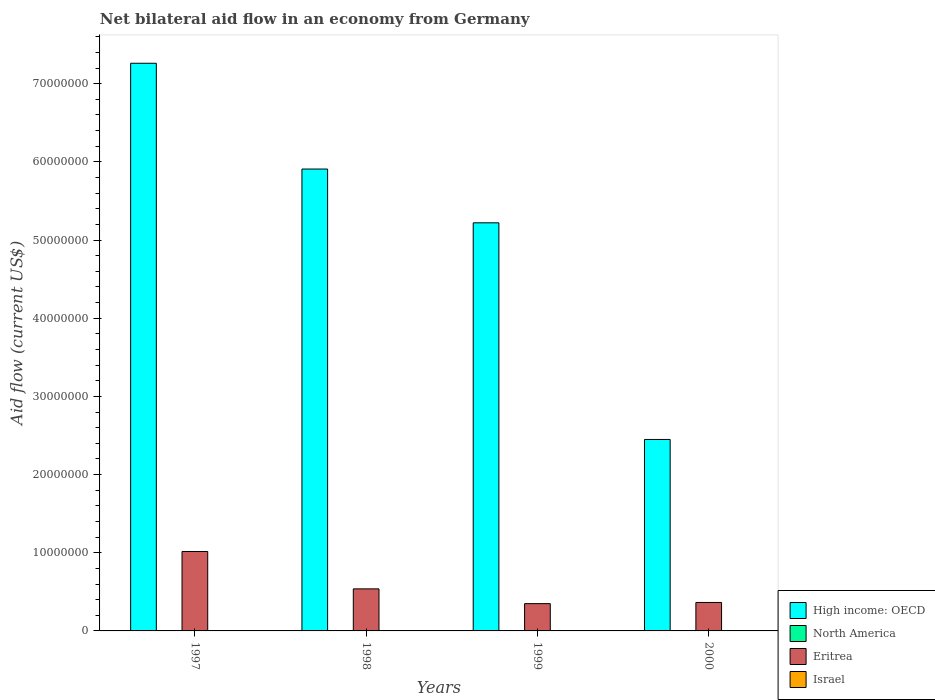How many groups of bars are there?
Your response must be concise. 4. Are the number of bars per tick equal to the number of legend labels?
Your answer should be very brief. No. Are the number of bars on each tick of the X-axis equal?
Offer a very short reply. No. In how many cases, is the number of bars for a given year not equal to the number of legend labels?
Your answer should be very brief. 4. What is the net bilateral aid flow in Eritrea in 1998?
Give a very brief answer. 5.38e+06. Across all years, what is the maximum net bilateral aid flow in Eritrea?
Provide a short and direct response. 1.02e+07. Across all years, what is the minimum net bilateral aid flow in High income: OECD?
Ensure brevity in your answer.  2.45e+07. In which year was the net bilateral aid flow in Eritrea maximum?
Ensure brevity in your answer.  1997. What is the total net bilateral aid flow in High income: OECD in the graph?
Your response must be concise. 2.08e+08. What is the difference between the net bilateral aid flow in Israel in 1998 and the net bilateral aid flow in High income: OECD in 1999?
Your response must be concise. -5.22e+07. What is the average net bilateral aid flow in North America per year?
Ensure brevity in your answer.  1.25e+04. In the year 1998, what is the difference between the net bilateral aid flow in Eritrea and net bilateral aid flow in High income: OECD?
Your answer should be compact. -5.37e+07. What is the ratio of the net bilateral aid flow in Eritrea in 1997 to that in 2000?
Ensure brevity in your answer.  2.79. Is the net bilateral aid flow in Eritrea in 1997 less than that in 2000?
Make the answer very short. No. What is the difference between the highest and the second highest net bilateral aid flow in Eritrea?
Your answer should be very brief. 4.78e+06. Is the sum of the net bilateral aid flow in High income: OECD in 1999 and 2000 greater than the maximum net bilateral aid flow in North America across all years?
Your response must be concise. Yes. Is it the case that in every year, the sum of the net bilateral aid flow in North America and net bilateral aid flow in High income: OECD is greater than the sum of net bilateral aid flow in Eritrea and net bilateral aid flow in Israel?
Make the answer very short. No. How many bars are there?
Keep it short and to the point. 11. Are all the bars in the graph horizontal?
Your answer should be compact. No. How many years are there in the graph?
Your answer should be very brief. 4. Does the graph contain any zero values?
Provide a succinct answer. Yes. Does the graph contain grids?
Your answer should be very brief. No. Where does the legend appear in the graph?
Provide a short and direct response. Bottom right. How many legend labels are there?
Ensure brevity in your answer.  4. What is the title of the graph?
Offer a very short reply. Net bilateral aid flow in an economy from Germany. Does "Vanuatu" appear as one of the legend labels in the graph?
Provide a short and direct response. No. What is the label or title of the X-axis?
Offer a terse response. Years. What is the label or title of the Y-axis?
Give a very brief answer. Aid flow (current US$). What is the Aid flow (current US$) of High income: OECD in 1997?
Ensure brevity in your answer.  7.26e+07. What is the Aid flow (current US$) in Eritrea in 1997?
Provide a succinct answer. 1.02e+07. What is the Aid flow (current US$) in High income: OECD in 1998?
Your response must be concise. 5.91e+07. What is the Aid flow (current US$) in Eritrea in 1998?
Provide a short and direct response. 5.38e+06. What is the Aid flow (current US$) of High income: OECD in 1999?
Make the answer very short. 5.22e+07. What is the Aid flow (current US$) of Eritrea in 1999?
Your response must be concise. 3.49e+06. What is the Aid flow (current US$) of High income: OECD in 2000?
Your answer should be very brief. 2.45e+07. What is the Aid flow (current US$) of North America in 2000?
Ensure brevity in your answer.  10000. What is the Aid flow (current US$) of Eritrea in 2000?
Provide a short and direct response. 3.64e+06. What is the Aid flow (current US$) in Israel in 2000?
Ensure brevity in your answer.  0. Across all years, what is the maximum Aid flow (current US$) of High income: OECD?
Give a very brief answer. 7.26e+07. Across all years, what is the maximum Aid flow (current US$) of Eritrea?
Make the answer very short. 1.02e+07. Across all years, what is the minimum Aid flow (current US$) of High income: OECD?
Your answer should be very brief. 2.45e+07. Across all years, what is the minimum Aid flow (current US$) in Eritrea?
Offer a very short reply. 3.49e+06. What is the total Aid flow (current US$) in High income: OECD in the graph?
Your answer should be very brief. 2.08e+08. What is the total Aid flow (current US$) of North America in the graph?
Give a very brief answer. 5.00e+04. What is the total Aid flow (current US$) in Eritrea in the graph?
Your response must be concise. 2.27e+07. What is the difference between the Aid flow (current US$) in High income: OECD in 1997 and that in 1998?
Ensure brevity in your answer.  1.35e+07. What is the difference between the Aid flow (current US$) in Eritrea in 1997 and that in 1998?
Your answer should be very brief. 4.78e+06. What is the difference between the Aid flow (current US$) in High income: OECD in 1997 and that in 1999?
Give a very brief answer. 2.04e+07. What is the difference between the Aid flow (current US$) in Eritrea in 1997 and that in 1999?
Ensure brevity in your answer.  6.67e+06. What is the difference between the Aid flow (current US$) of High income: OECD in 1997 and that in 2000?
Ensure brevity in your answer.  4.81e+07. What is the difference between the Aid flow (current US$) in Eritrea in 1997 and that in 2000?
Offer a terse response. 6.52e+06. What is the difference between the Aid flow (current US$) of High income: OECD in 1998 and that in 1999?
Provide a short and direct response. 6.88e+06. What is the difference between the Aid flow (current US$) in North America in 1998 and that in 1999?
Offer a very short reply. 0. What is the difference between the Aid flow (current US$) of Eritrea in 1998 and that in 1999?
Your response must be concise. 1.89e+06. What is the difference between the Aid flow (current US$) in High income: OECD in 1998 and that in 2000?
Your answer should be very brief. 3.46e+07. What is the difference between the Aid flow (current US$) of North America in 1998 and that in 2000?
Keep it short and to the point. 10000. What is the difference between the Aid flow (current US$) of Eritrea in 1998 and that in 2000?
Provide a short and direct response. 1.74e+06. What is the difference between the Aid flow (current US$) of High income: OECD in 1999 and that in 2000?
Offer a terse response. 2.77e+07. What is the difference between the Aid flow (current US$) in High income: OECD in 1997 and the Aid flow (current US$) in North America in 1998?
Make the answer very short. 7.26e+07. What is the difference between the Aid flow (current US$) in High income: OECD in 1997 and the Aid flow (current US$) in Eritrea in 1998?
Your response must be concise. 6.72e+07. What is the difference between the Aid flow (current US$) in High income: OECD in 1997 and the Aid flow (current US$) in North America in 1999?
Offer a very short reply. 7.26e+07. What is the difference between the Aid flow (current US$) in High income: OECD in 1997 and the Aid flow (current US$) in Eritrea in 1999?
Provide a succinct answer. 6.91e+07. What is the difference between the Aid flow (current US$) in High income: OECD in 1997 and the Aid flow (current US$) in North America in 2000?
Ensure brevity in your answer.  7.26e+07. What is the difference between the Aid flow (current US$) of High income: OECD in 1997 and the Aid flow (current US$) of Eritrea in 2000?
Your answer should be very brief. 6.90e+07. What is the difference between the Aid flow (current US$) in High income: OECD in 1998 and the Aid flow (current US$) in North America in 1999?
Give a very brief answer. 5.91e+07. What is the difference between the Aid flow (current US$) in High income: OECD in 1998 and the Aid flow (current US$) in Eritrea in 1999?
Provide a short and direct response. 5.56e+07. What is the difference between the Aid flow (current US$) of North America in 1998 and the Aid flow (current US$) of Eritrea in 1999?
Keep it short and to the point. -3.47e+06. What is the difference between the Aid flow (current US$) in High income: OECD in 1998 and the Aid flow (current US$) in North America in 2000?
Make the answer very short. 5.91e+07. What is the difference between the Aid flow (current US$) of High income: OECD in 1998 and the Aid flow (current US$) of Eritrea in 2000?
Make the answer very short. 5.54e+07. What is the difference between the Aid flow (current US$) in North America in 1998 and the Aid flow (current US$) in Eritrea in 2000?
Your answer should be compact. -3.62e+06. What is the difference between the Aid flow (current US$) of High income: OECD in 1999 and the Aid flow (current US$) of North America in 2000?
Give a very brief answer. 5.22e+07. What is the difference between the Aid flow (current US$) of High income: OECD in 1999 and the Aid flow (current US$) of Eritrea in 2000?
Your answer should be very brief. 4.86e+07. What is the difference between the Aid flow (current US$) in North America in 1999 and the Aid flow (current US$) in Eritrea in 2000?
Your response must be concise. -3.62e+06. What is the average Aid flow (current US$) of High income: OECD per year?
Your answer should be compact. 5.21e+07. What is the average Aid flow (current US$) of North America per year?
Your answer should be very brief. 1.25e+04. What is the average Aid flow (current US$) of Eritrea per year?
Your answer should be compact. 5.67e+06. In the year 1997, what is the difference between the Aid flow (current US$) of High income: OECD and Aid flow (current US$) of Eritrea?
Your response must be concise. 6.24e+07. In the year 1998, what is the difference between the Aid flow (current US$) in High income: OECD and Aid flow (current US$) in North America?
Make the answer very short. 5.91e+07. In the year 1998, what is the difference between the Aid flow (current US$) of High income: OECD and Aid flow (current US$) of Eritrea?
Provide a short and direct response. 5.37e+07. In the year 1998, what is the difference between the Aid flow (current US$) of North America and Aid flow (current US$) of Eritrea?
Keep it short and to the point. -5.36e+06. In the year 1999, what is the difference between the Aid flow (current US$) in High income: OECD and Aid flow (current US$) in North America?
Keep it short and to the point. 5.22e+07. In the year 1999, what is the difference between the Aid flow (current US$) in High income: OECD and Aid flow (current US$) in Eritrea?
Offer a terse response. 4.87e+07. In the year 1999, what is the difference between the Aid flow (current US$) of North America and Aid flow (current US$) of Eritrea?
Your answer should be very brief. -3.47e+06. In the year 2000, what is the difference between the Aid flow (current US$) of High income: OECD and Aid flow (current US$) of North America?
Your answer should be compact. 2.45e+07. In the year 2000, what is the difference between the Aid flow (current US$) of High income: OECD and Aid flow (current US$) of Eritrea?
Make the answer very short. 2.08e+07. In the year 2000, what is the difference between the Aid flow (current US$) in North America and Aid flow (current US$) in Eritrea?
Give a very brief answer. -3.63e+06. What is the ratio of the Aid flow (current US$) in High income: OECD in 1997 to that in 1998?
Provide a succinct answer. 1.23. What is the ratio of the Aid flow (current US$) of Eritrea in 1997 to that in 1998?
Your response must be concise. 1.89. What is the ratio of the Aid flow (current US$) in High income: OECD in 1997 to that in 1999?
Your response must be concise. 1.39. What is the ratio of the Aid flow (current US$) in Eritrea in 1997 to that in 1999?
Provide a succinct answer. 2.91. What is the ratio of the Aid flow (current US$) in High income: OECD in 1997 to that in 2000?
Provide a short and direct response. 2.96. What is the ratio of the Aid flow (current US$) in Eritrea in 1997 to that in 2000?
Provide a short and direct response. 2.79. What is the ratio of the Aid flow (current US$) in High income: OECD in 1998 to that in 1999?
Provide a short and direct response. 1.13. What is the ratio of the Aid flow (current US$) of Eritrea in 1998 to that in 1999?
Offer a very short reply. 1.54. What is the ratio of the Aid flow (current US$) of High income: OECD in 1998 to that in 2000?
Ensure brevity in your answer.  2.41. What is the ratio of the Aid flow (current US$) of Eritrea in 1998 to that in 2000?
Your response must be concise. 1.48. What is the ratio of the Aid flow (current US$) of High income: OECD in 1999 to that in 2000?
Offer a very short reply. 2.13. What is the ratio of the Aid flow (current US$) of Eritrea in 1999 to that in 2000?
Offer a terse response. 0.96. What is the difference between the highest and the second highest Aid flow (current US$) in High income: OECD?
Make the answer very short. 1.35e+07. What is the difference between the highest and the second highest Aid flow (current US$) of Eritrea?
Offer a very short reply. 4.78e+06. What is the difference between the highest and the lowest Aid flow (current US$) in High income: OECD?
Offer a terse response. 4.81e+07. What is the difference between the highest and the lowest Aid flow (current US$) of Eritrea?
Ensure brevity in your answer.  6.67e+06. 